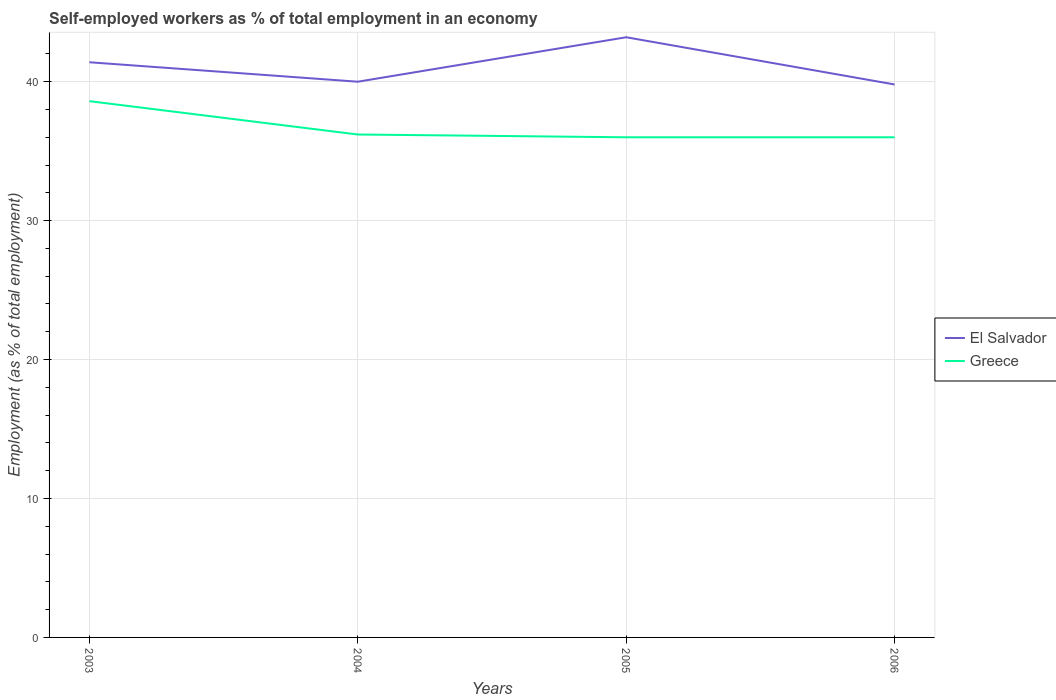How many different coloured lines are there?
Make the answer very short. 2. In which year was the percentage of self-employed workers in Greece maximum?
Your answer should be very brief. 2005. What is the difference between the highest and the second highest percentage of self-employed workers in El Salvador?
Make the answer very short. 3.4. Is the percentage of self-employed workers in El Salvador strictly greater than the percentage of self-employed workers in Greece over the years?
Ensure brevity in your answer.  No. How many lines are there?
Your response must be concise. 2. What is the difference between two consecutive major ticks on the Y-axis?
Your answer should be very brief. 10. Are the values on the major ticks of Y-axis written in scientific E-notation?
Your answer should be very brief. No. Does the graph contain any zero values?
Give a very brief answer. No. Where does the legend appear in the graph?
Keep it short and to the point. Center right. How many legend labels are there?
Keep it short and to the point. 2. What is the title of the graph?
Your answer should be compact. Self-employed workers as % of total employment in an economy. What is the label or title of the X-axis?
Your answer should be very brief. Years. What is the label or title of the Y-axis?
Your response must be concise. Employment (as % of total employment). What is the Employment (as % of total employment) in El Salvador in 2003?
Ensure brevity in your answer.  41.4. What is the Employment (as % of total employment) in Greece in 2003?
Provide a succinct answer. 38.6. What is the Employment (as % of total employment) in Greece in 2004?
Keep it short and to the point. 36.2. What is the Employment (as % of total employment) in El Salvador in 2005?
Provide a short and direct response. 43.2. What is the Employment (as % of total employment) of Greece in 2005?
Your answer should be very brief. 36. What is the Employment (as % of total employment) of El Salvador in 2006?
Make the answer very short. 39.8. Across all years, what is the maximum Employment (as % of total employment) of El Salvador?
Keep it short and to the point. 43.2. Across all years, what is the maximum Employment (as % of total employment) of Greece?
Offer a terse response. 38.6. Across all years, what is the minimum Employment (as % of total employment) of El Salvador?
Your answer should be compact. 39.8. What is the total Employment (as % of total employment) in El Salvador in the graph?
Provide a succinct answer. 164.4. What is the total Employment (as % of total employment) in Greece in the graph?
Your answer should be compact. 146.8. What is the difference between the Employment (as % of total employment) in Greece in 2003 and that in 2004?
Make the answer very short. 2.4. What is the difference between the Employment (as % of total employment) in El Salvador in 2003 and that in 2005?
Offer a terse response. -1.8. What is the difference between the Employment (as % of total employment) of Greece in 2003 and that in 2006?
Your response must be concise. 2.6. What is the difference between the Employment (as % of total employment) in Greece in 2004 and that in 2005?
Provide a short and direct response. 0.2. What is the difference between the Employment (as % of total employment) of El Salvador in 2004 and that in 2006?
Ensure brevity in your answer.  0.2. What is the difference between the Employment (as % of total employment) of Greece in 2005 and that in 2006?
Your response must be concise. 0. What is the difference between the Employment (as % of total employment) of El Salvador in 2003 and the Employment (as % of total employment) of Greece in 2006?
Your answer should be very brief. 5.4. What is the difference between the Employment (as % of total employment) of El Salvador in 2004 and the Employment (as % of total employment) of Greece in 2005?
Your answer should be very brief. 4. What is the difference between the Employment (as % of total employment) of El Salvador in 2004 and the Employment (as % of total employment) of Greece in 2006?
Offer a very short reply. 4. What is the average Employment (as % of total employment) in El Salvador per year?
Your answer should be compact. 41.1. What is the average Employment (as % of total employment) of Greece per year?
Make the answer very short. 36.7. In the year 2004, what is the difference between the Employment (as % of total employment) of El Salvador and Employment (as % of total employment) of Greece?
Give a very brief answer. 3.8. In the year 2005, what is the difference between the Employment (as % of total employment) of El Salvador and Employment (as % of total employment) of Greece?
Provide a succinct answer. 7.2. In the year 2006, what is the difference between the Employment (as % of total employment) of El Salvador and Employment (as % of total employment) of Greece?
Offer a very short reply. 3.8. What is the ratio of the Employment (as % of total employment) in El Salvador in 2003 to that in 2004?
Provide a short and direct response. 1.03. What is the ratio of the Employment (as % of total employment) in Greece in 2003 to that in 2004?
Your response must be concise. 1.07. What is the ratio of the Employment (as % of total employment) of Greece in 2003 to that in 2005?
Offer a very short reply. 1.07. What is the ratio of the Employment (as % of total employment) of El Salvador in 2003 to that in 2006?
Give a very brief answer. 1.04. What is the ratio of the Employment (as % of total employment) of Greece in 2003 to that in 2006?
Offer a very short reply. 1.07. What is the ratio of the Employment (as % of total employment) of El Salvador in 2004 to that in 2005?
Ensure brevity in your answer.  0.93. What is the ratio of the Employment (as % of total employment) in Greece in 2004 to that in 2005?
Provide a short and direct response. 1.01. What is the ratio of the Employment (as % of total employment) of Greece in 2004 to that in 2006?
Make the answer very short. 1.01. What is the ratio of the Employment (as % of total employment) in El Salvador in 2005 to that in 2006?
Your response must be concise. 1.09. What is the difference between the highest and the second highest Employment (as % of total employment) in El Salvador?
Your response must be concise. 1.8. What is the difference between the highest and the second highest Employment (as % of total employment) in Greece?
Provide a short and direct response. 2.4. What is the difference between the highest and the lowest Employment (as % of total employment) in El Salvador?
Keep it short and to the point. 3.4. 